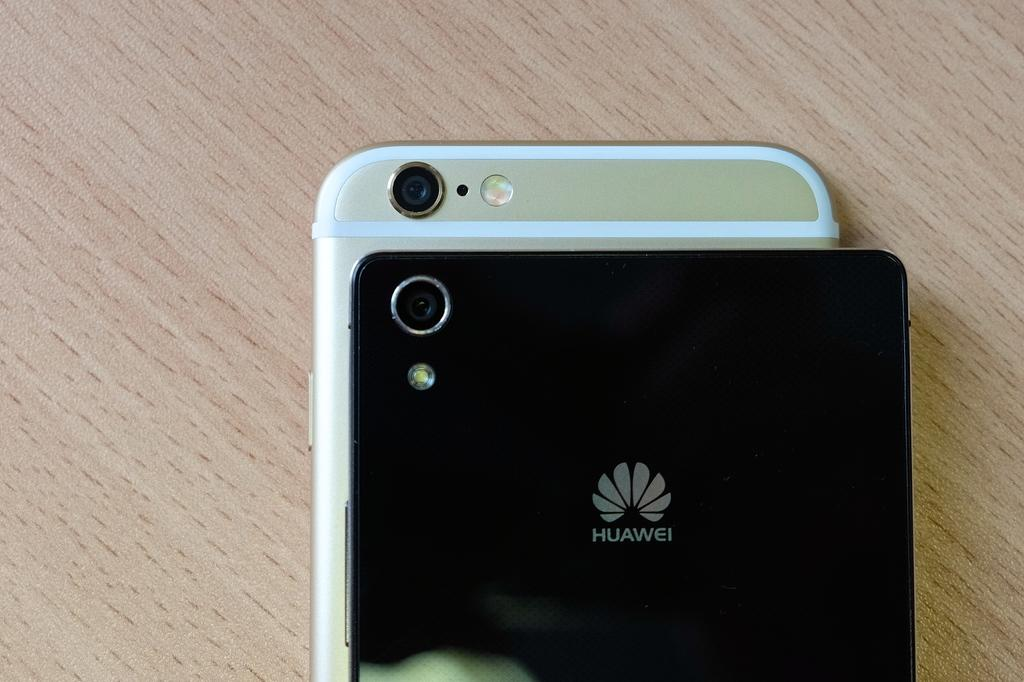<image>
Share a concise interpretation of the image provided. A black Huawei cell phone lies on top of another cell phone. 